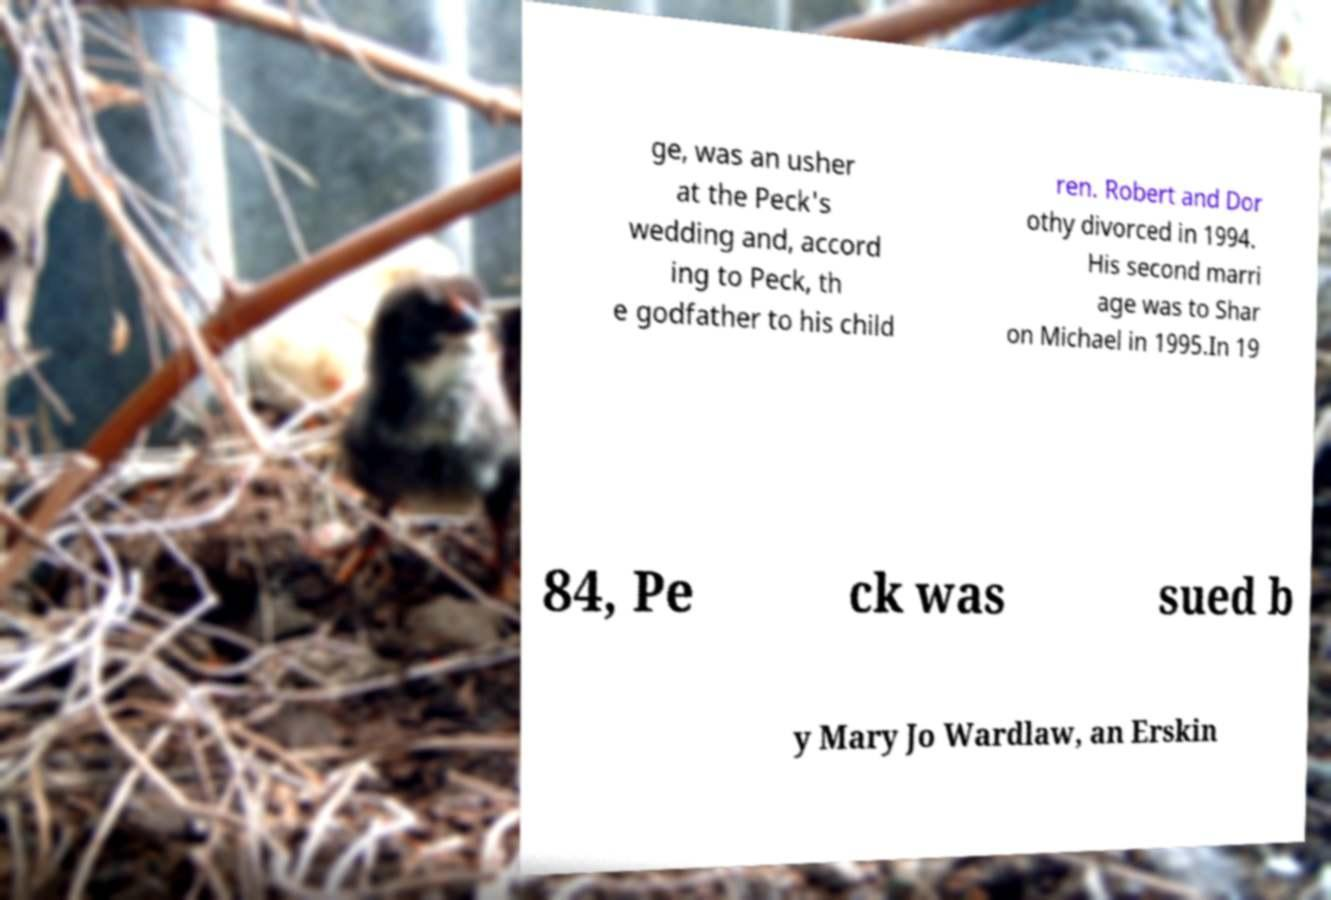There's text embedded in this image that I need extracted. Can you transcribe it verbatim? ge, was an usher at the Peck's wedding and, accord ing to Peck, th e godfather to his child ren. Robert and Dor othy divorced in 1994. His second marri age was to Shar on Michael in 1995.In 19 84, Pe ck was sued b y Mary Jo Wardlaw, an Erskin 